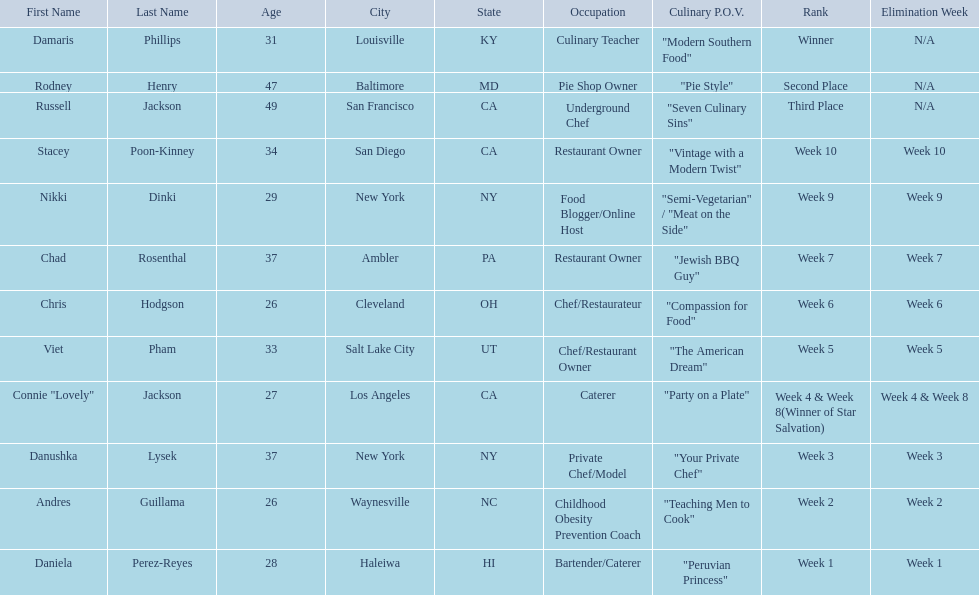Who are the  food network stars? Damaris Phillips, Rodney Henry, Russell Jackson, Stacey Poon-Kinney, Nikki Dinki, Chad Rosenthal, Chris Hodgson, Viet Pham, Connie "Lovely" Jackson, Danushka Lysek, Andres Guillama, Daniela Perez-Reyes. When did nikki dinki get eliminated? Week 9. When did viet pham get eliminated? Week 5. Which week came first? Week 5. Who was it that was eliminated week 5? Viet Pham. 